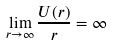Convert formula to latex. <formula><loc_0><loc_0><loc_500><loc_500>\lim _ { r \to \infty } \frac { U ( r ) } r = \infty</formula> 